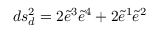<formula> <loc_0><loc_0><loc_500><loc_500>d s _ { d } ^ { 2 } = 2 \widetilde { e } ^ { 3 } \widetilde { e } ^ { 4 } + 2 \widetilde { e } ^ { 1 } \widetilde { e } ^ { 2 }</formula> 